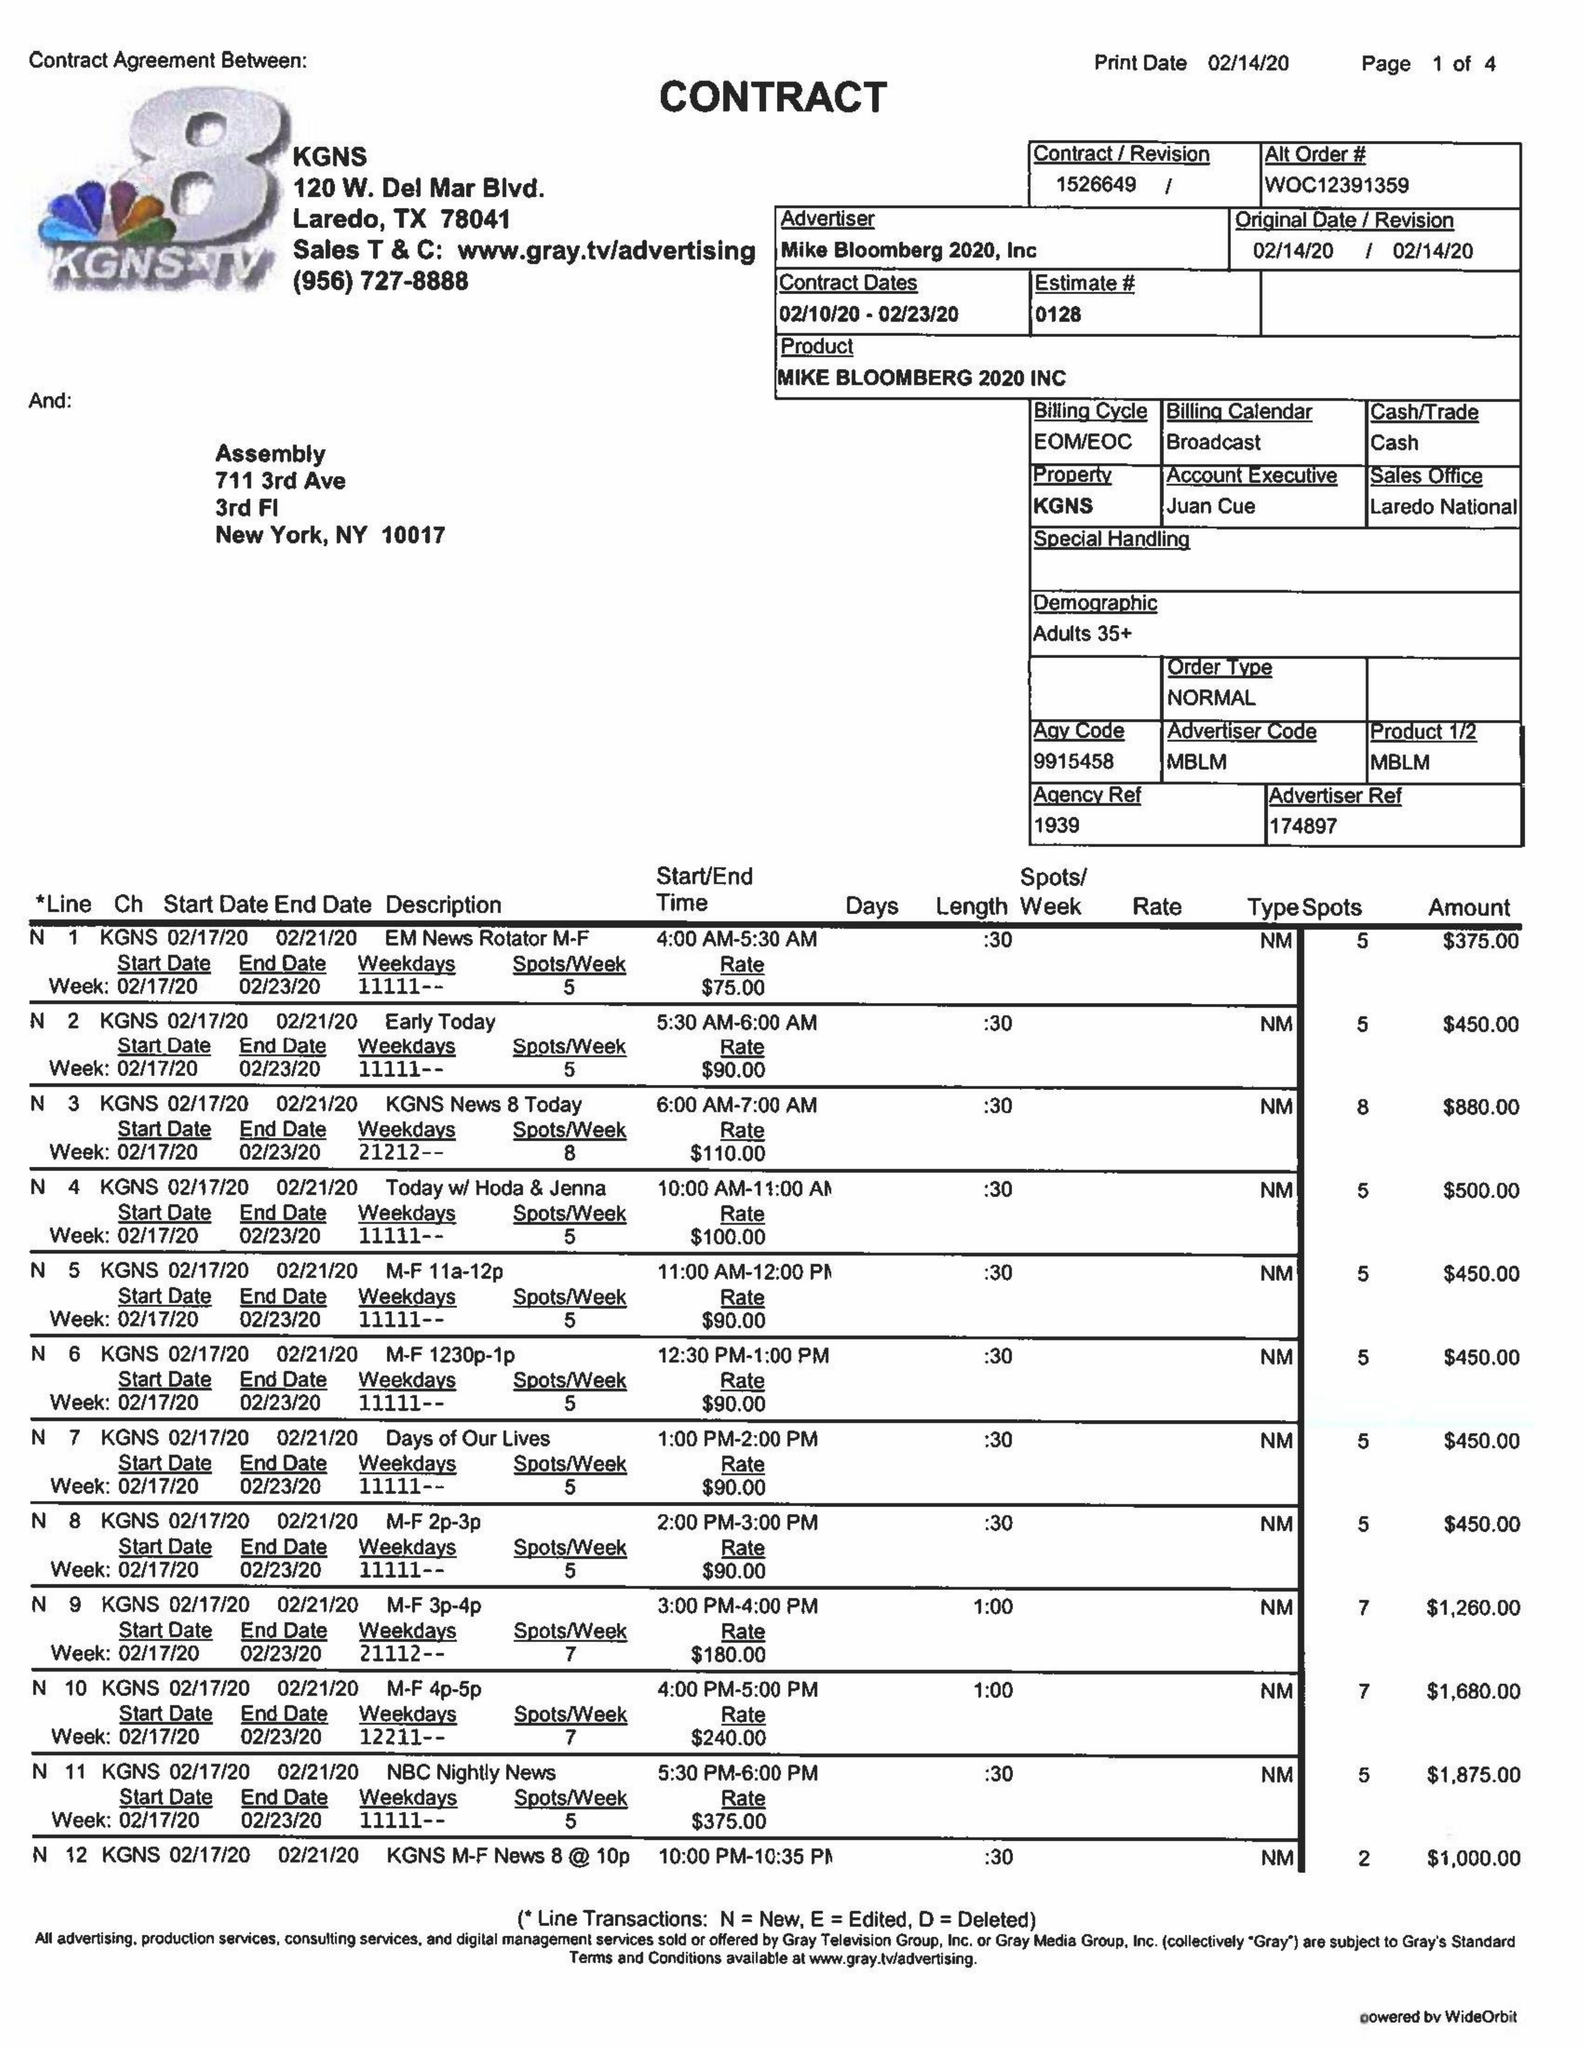What is the value for the gross_amount?
Answer the question using a single word or phrase. 47675.00 